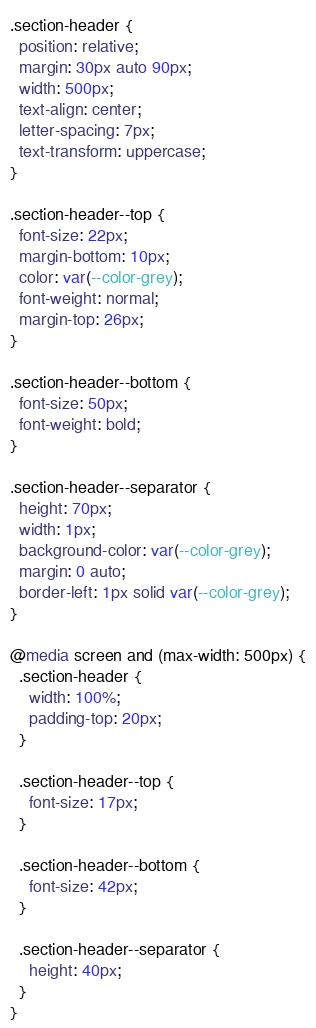Convert code to text. <code><loc_0><loc_0><loc_500><loc_500><_CSS_>.section-header {
  position: relative;
  margin: 30px auto 90px;
  width: 500px;
  text-align: center;
  letter-spacing: 7px;
  text-transform: uppercase;
}

.section-header--top {
  font-size: 22px;
  margin-bottom: 10px;
  color: var(--color-grey);
  font-weight: normal;
  margin-top: 26px;
}

.section-header--bottom {
  font-size: 50px;
  font-weight: bold;
}

.section-header--separator {
  height: 70px;
  width: 1px;
  background-color: var(--color-grey);
  margin: 0 auto;
  border-left: 1px solid var(--color-grey);
}

@media screen and (max-width: 500px) {
  .section-header {
    width: 100%;
    padding-top: 20px;
  }

  .section-header--top {
    font-size: 17px;
  }

  .section-header--bottom {
    font-size: 42px;
  }

  .section-header--separator {
    height: 40px;
  }
}
</code> 